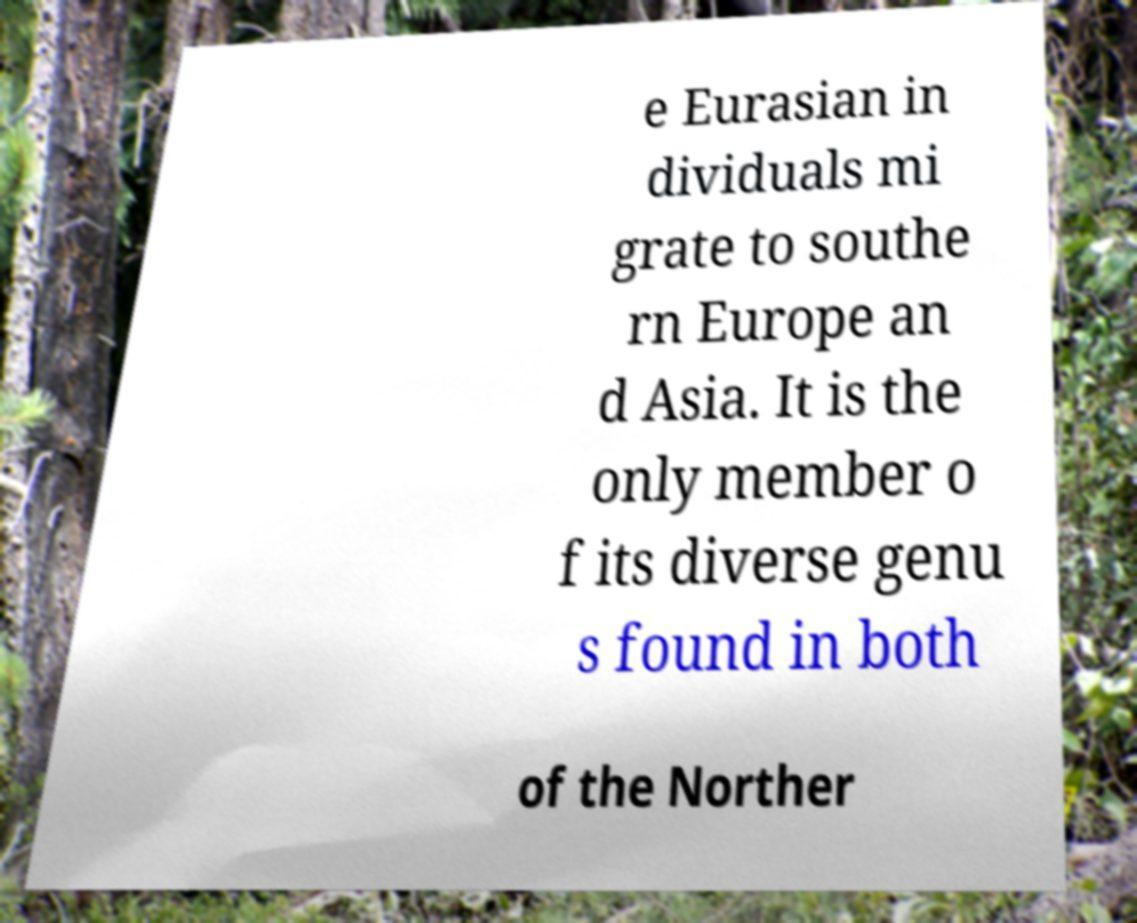There's text embedded in this image that I need extracted. Can you transcribe it verbatim? e Eurasian in dividuals mi grate to southe rn Europe an d Asia. It is the only member o f its diverse genu s found in both of the Norther 